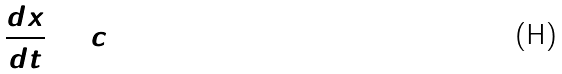Convert formula to latex. <formula><loc_0><loc_0><loc_500><loc_500>\frac { d x } { d t } = c</formula> 